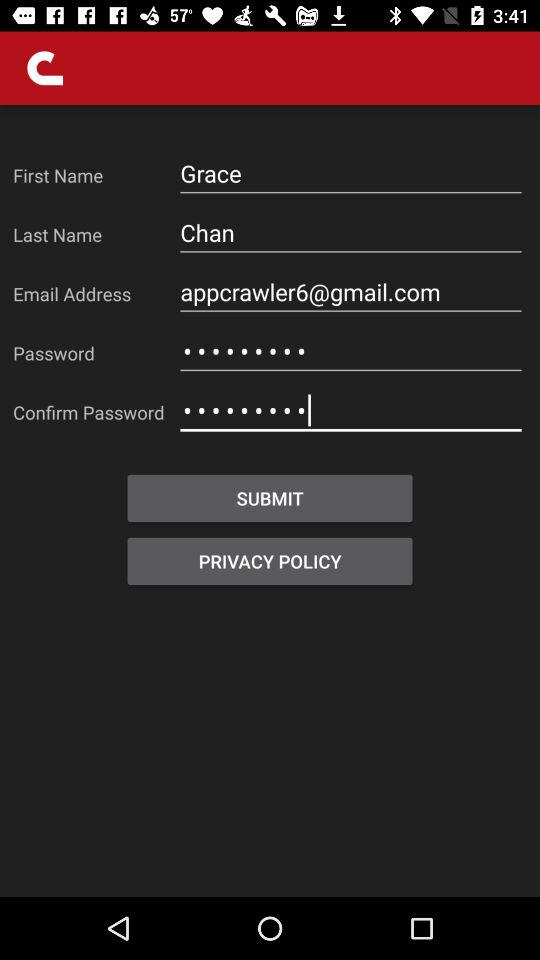What is the first name? The first name is Grace. 